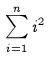Convert formula to latex. <formula><loc_0><loc_0><loc_500><loc_500>\sum _ { i = 1 } ^ { n } i ^ { 2 }</formula> 